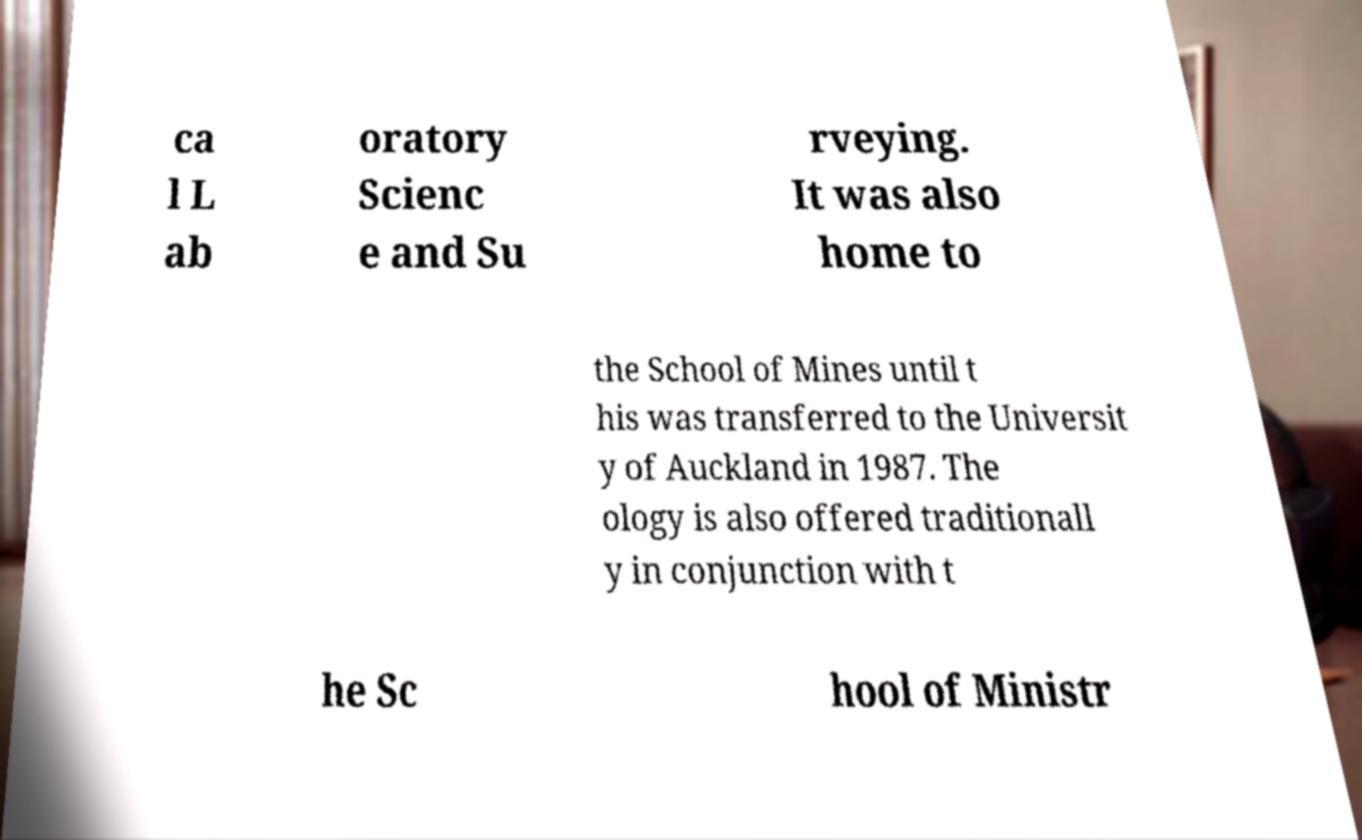Can you accurately transcribe the text from the provided image for me? ca l L ab oratory Scienc e and Su rveying. It was also home to the School of Mines until t his was transferred to the Universit y of Auckland in 1987. The ology is also offered traditionall y in conjunction with t he Sc hool of Ministr 